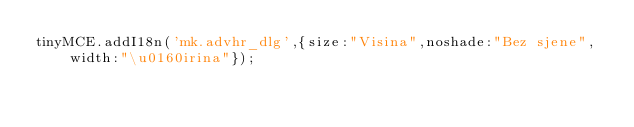Convert code to text. <code><loc_0><loc_0><loc_500><loc_500><_JavaScript_>tinyMCE.addI18n('mk.advhr_dlg',{size:"Visina",noshade:"Bez sjene",width:"\u0160irina"});</code> 